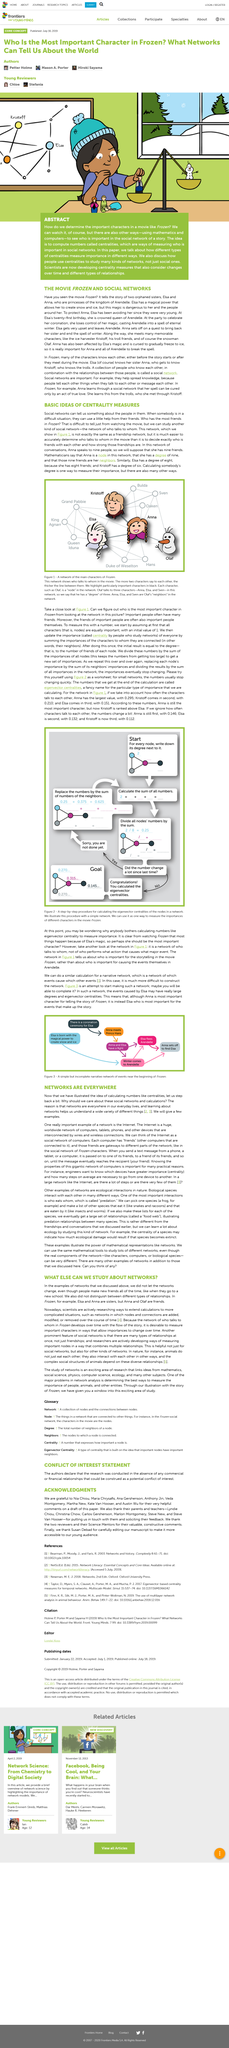Indicate a few pertinent items in this graphic. Kristoff comes in second place with a value of 0.210... If we disregard the frequency of characters' conversations, Anna is in first place. Anna is the most important character for the storytelling of Frozen. In this network, Anna has a degree of nine. Each character in the network refers to a node. 